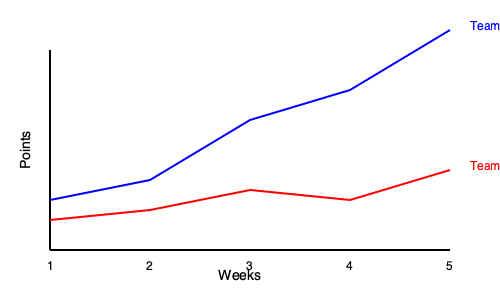Based on the line chart showing fantasy points scored by Team A and Team B over 5 weeks, which team demonstrates a more consistent performance, and what does this suggest about their potential success in future matchups? To determine which team demonstrates more consistent performance and analyze their potential success in future matchups, we need to examine the trends for both teams:

1. Team A (Blue line):
   - Week 1 to 2: Slight increase
   - Week 2 to 3: Significant increase
   - Week 3 to 4: Moderate increase
   - Week 4 to 5: Large increase
   - Overall trend: Steadily increasing points each week

2. Team B (Red line):
   - Week 1 to 2: Slight decrease
   - Week 2 to 3: Moderate decrease
   - Week 3 to 4: Slight increase
   - Week 4 to 5: Moderate decrease
   - Overall trend: Fluctuating, but generally decreasing

3. Consistency analysis:
   - Team A shows a consistent upward trend, indicating improving performance each week.
   - Team B shows more fluctuations, with an overall downward trend.

4. Potential success in future matchups:
   - Team A's consistent improvement suggests they are likely to continue performing well and potentially score even higher in future weeks.
   - Team B's inconsistent performance and overall downward trend indicate they may struggle in future matchups unless they can reverse the trend.

Based on this analysis, Team A demonstrates more consistent performance, showing steady improvement week over week. This consistency and upward trend suggest that Team A has a higher potential for success in future matchups compared to Team B.
Answer: Team A; higher potential for future success due to consistent improvement. 